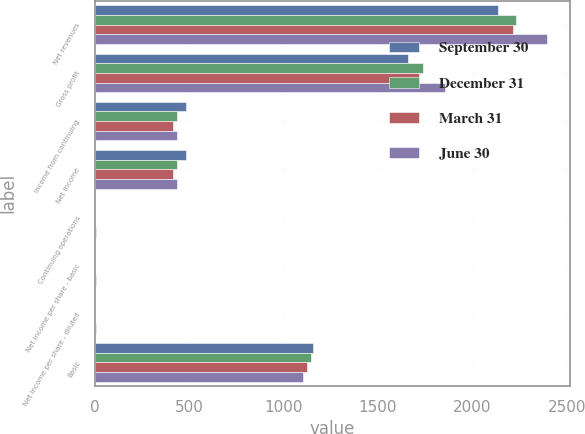Convert chart to OTSL. <chart><loc_0><loc_0><loc_500><loc_500><stacked_bar_chart><ecel><fcel>Net revenues<fcel>Gross profit<fcel>Income from continuing<fcel>Net income<fcel>Continuing operations<fcel>Net income per share - basic<fcel>Net income per share - diluted<fcel>Basic<nl><fcel>September 30<fcel>2137<fcel>1660<fcel>482<fcel>482<fcel>0.42<fcel>0.42<fcel>0.41<fcel>1159<nl><fcel>December 31<fcel>2230<fcel>1737<fcel>437<fcel>435<fcel>0.38<fcel>0.38<fcel>0.38<fcel>1144<nl><fcel>March 31<fcel>2217<fcel>1719<fcel>418<fcel>413<fcel>0.37<fcel>0.37<fcel>0.36<fcel>1126<nl><fcel>June 30<fcel>2395<fcel>1856<fcel>436<fcel>436<fcel>5.38<fcel>5.37<fcel>5.3<fcel>1106<nl></chart> 